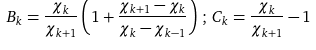<formula> <loc_0><loc_0><loc_500><loc_500>B _ { k } = \frac { \chi _ { k } } { \chi _ { k + 1 } } \left ( 1 + \frac { \chi _ { k + 1 } - \chi _ { k } } { \chi _ { k } - \chi _ { k - 1 } } \right ) \, ; \, C _ { k } = \frac { \chi _ { k } } { \chi _ { k + 1 } } - 1 \\ \\</formula> 